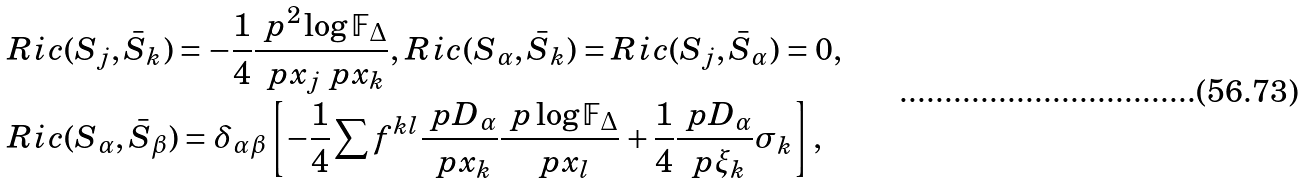Convert formula to latex. <formula><loc_0><loc_0><loc_500><loc_500>& R i c ( S _ { j } , \bar { S } _ { k } ) = - \frac { 1 } { 4 } \frac { \ p ^ { 2 } \log \mathbb { F } _ { \Delta } } { \ p x _ { j } \ p x _ { k } } , \, R i c ( S _ { \alpha } , \bar { S } _ { k } ) = R i c ( S _ { j } , \bar { S } _ { \alpha } ) = 0 , \, \\ & R i c ( S _ { \alpha } , \bar { S } _ { \beta } ) = \delta _ { \alpha \beta } \left [ - \frac { 1 } { 4 } \sum f ^ { k l } \frac { \ p D _ { \alpha } } { \ p x _ { k } } \frac { \ p \log \mathbb { F } _ { \Delta } } { \ p x _ { l } } + \frac { 1 } { 4 } \frac { \ p D _ { \alpha } } { \ p \xi _ { k } } \sigma _ { k } \right ] ,</formula> 